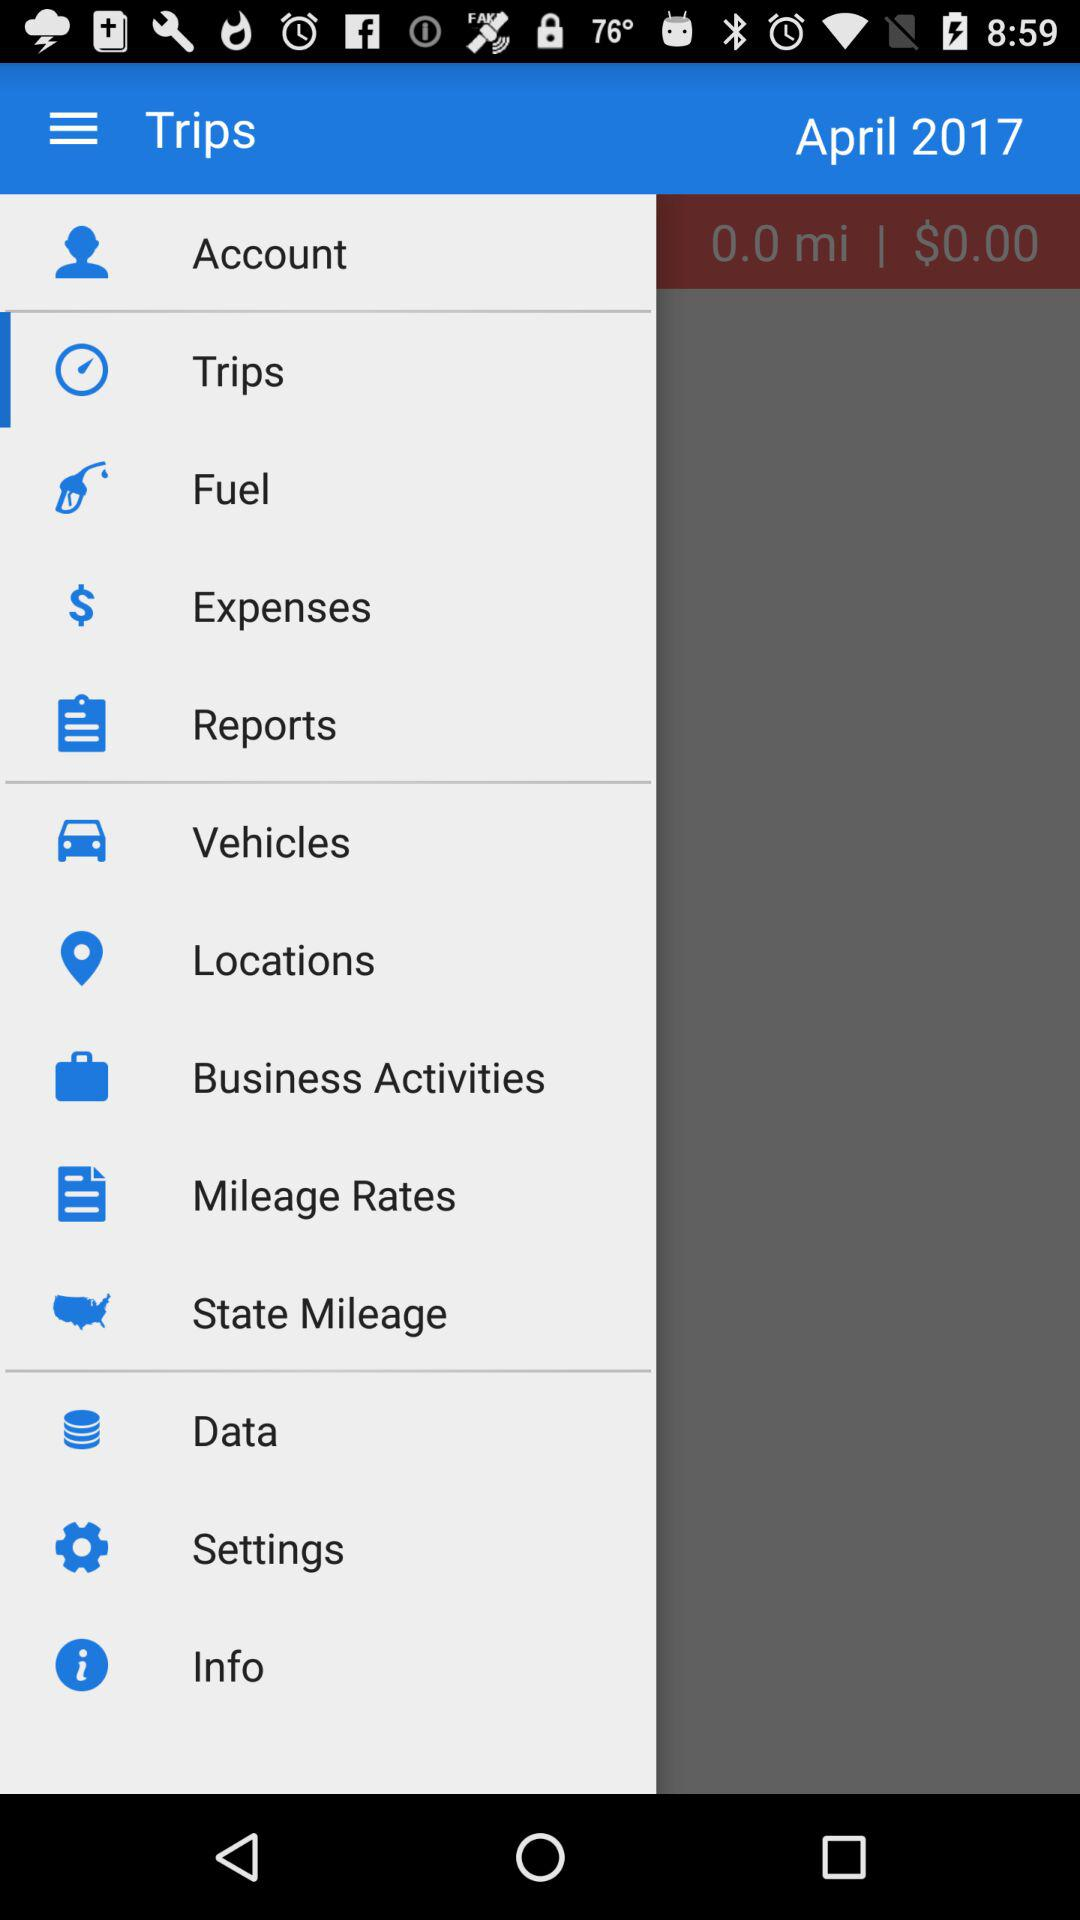What is the mentioned month? The mentioned month is April. 